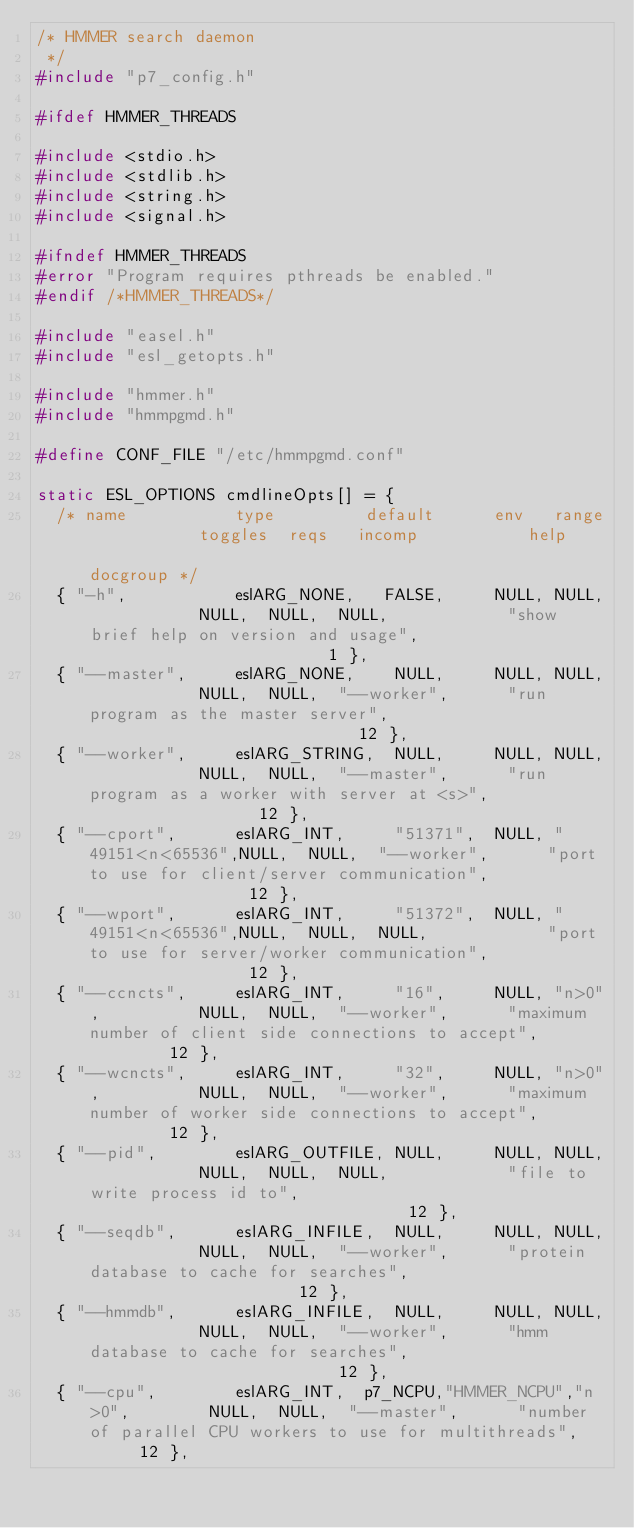<code> <loc_0><loc_0><loc_500><loc_500><_C_>/* HMMER search daemon
 */
#include "p7_config.h"

#ifdef HMMER_THREADS

#include <stdio.h>
#include <stdlib.h>
#include <string.h>
#include <signal.h>

#ifndef HMMER_THREADS
#error "Program requires pthreads be enabled."
#endif /*HMMER_THREADS*/

#include "easel.h"
#include "esl_getopts.h"

#include "hmmer.h"
#include "hmmpgmd.h"

#define CONF_FILE "/etc/hmmpgmd.conf"

static ESL_OPTIONS cmdlineOpts[] = {
  /* name           type         default      env   range           toggles  reqs   incomp           help                                                     docgroup */
  { "-h",           eslARG_NONE,   FALSE,     NULL, NULL,           NULL,  NULL,  NULL,            "show brief help on version and usage",                         1 },
  { "--master",     eslARG_NONE,    NULL,     NULL, NULL,           NULL,  NULL,  "--worker",      "run program as the master server",                            12 },
  { "--worker",     eslARG_STRING,  NULL,     NULL, NULL,           NULL,  NULL,  "--master",      "run program as a worker with server at <s>",                  12 },
  { "--cport",      eslARG_INT,     "51371",  NULL, "49151<n<65536",NULL,  NULL,  "--worker",      "port to use for client/server communication",                 12 },
  { "--wport",      eslARG_INT,     "51372",  NULL, "49151<n<65536",NULL,  NULL,  NULL,            "port to use for server/worker communication",                 12 },
  { "--ccncts",     eslARG_INT,     "16",     NULL, "n>0",          NULL,  NULL,  "--worker",      "maximum number of client side connections to accept",         12 },
  { "--wcncts",     eslARG_INT,     "32",     NULL, "n>0",          NULL,  NULL,  "--worker",      "maximum number of worker side connections to accept",         12 },
  { "--pid",        eslARG_OUTFILE, NULL,     NULL, NULL,           NULL,  NULL,  NULL,            "file to write process id to",                                 12 },
  { "--seqdb",      eslARG_INFILE,  NULL,     NULL, NULL,           NULL,  NULL,  "--worker",      "protein database to cache for searches",                      12 },
  { "--hmmdb",      eslARG_INFILE,  NULL,     NULL, NULL,           NULL,  NULL,  "--worker",      "hmm database to cache for searches",                          12 },
  { "--cpu",        eslARG_INT,  p7_NCPU,"HMMER_NCPU","n>0",        NULL,  NULL,  "--master",      "number of parallel CPU workers to use for multithreads",      12 },</code> 